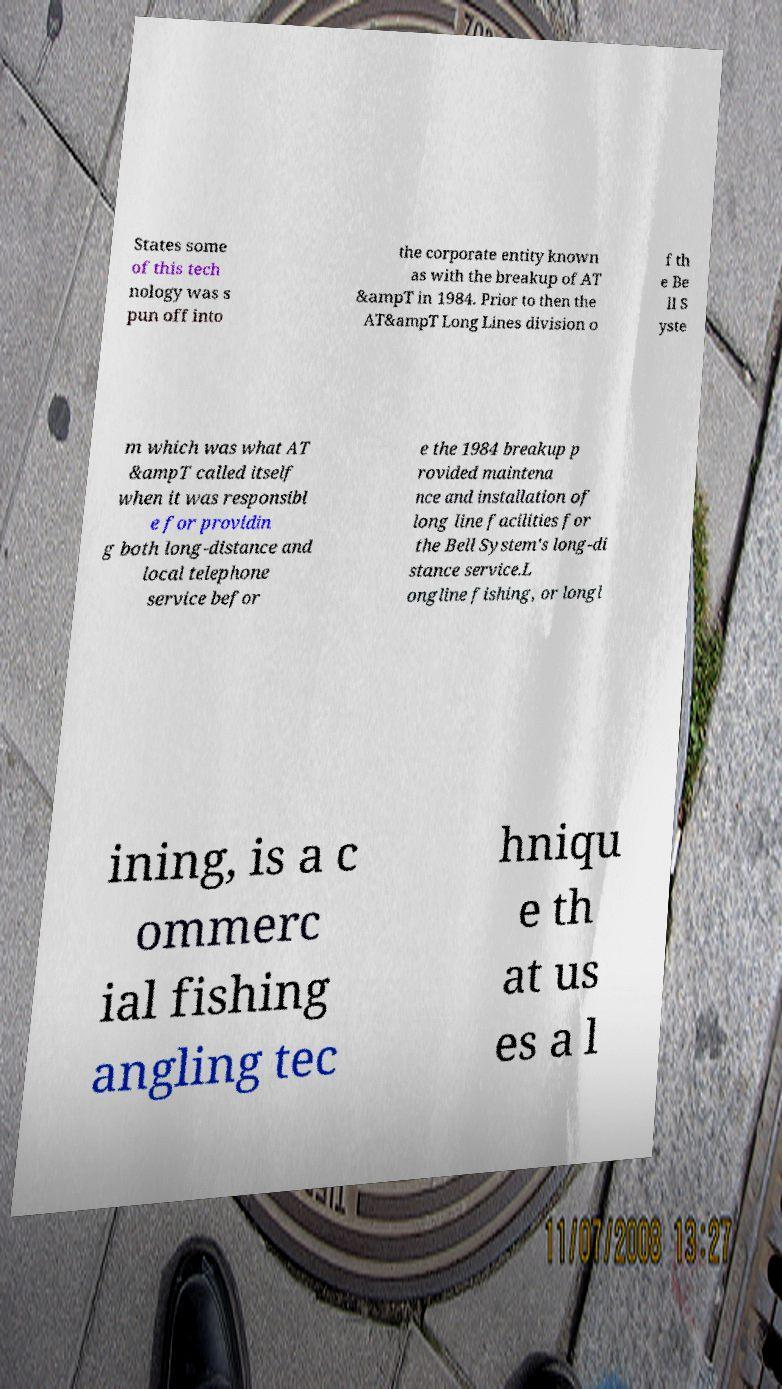Can you read and provide the text displayed in the image?This photo seems to have some interesting text. Can you extract and type it out for me? States some of this tech nology was s pun off into the corporate entity known as with the breakup of AT &ampT in 1984. Prior to then the AT&ampT Long Lines division o f th e Be ll S yste m which was what AT &ampT called itself when it was responsibl e for providin g both long-distance and local telephone service befor e the 1984 breakup p rovided maintena nce and installation of long line facilities for the Bell System's long-di stance service.L ongline fishing, or longl ining, is a c ommerc ial fishing angling tec hniqu e th at us es a l 